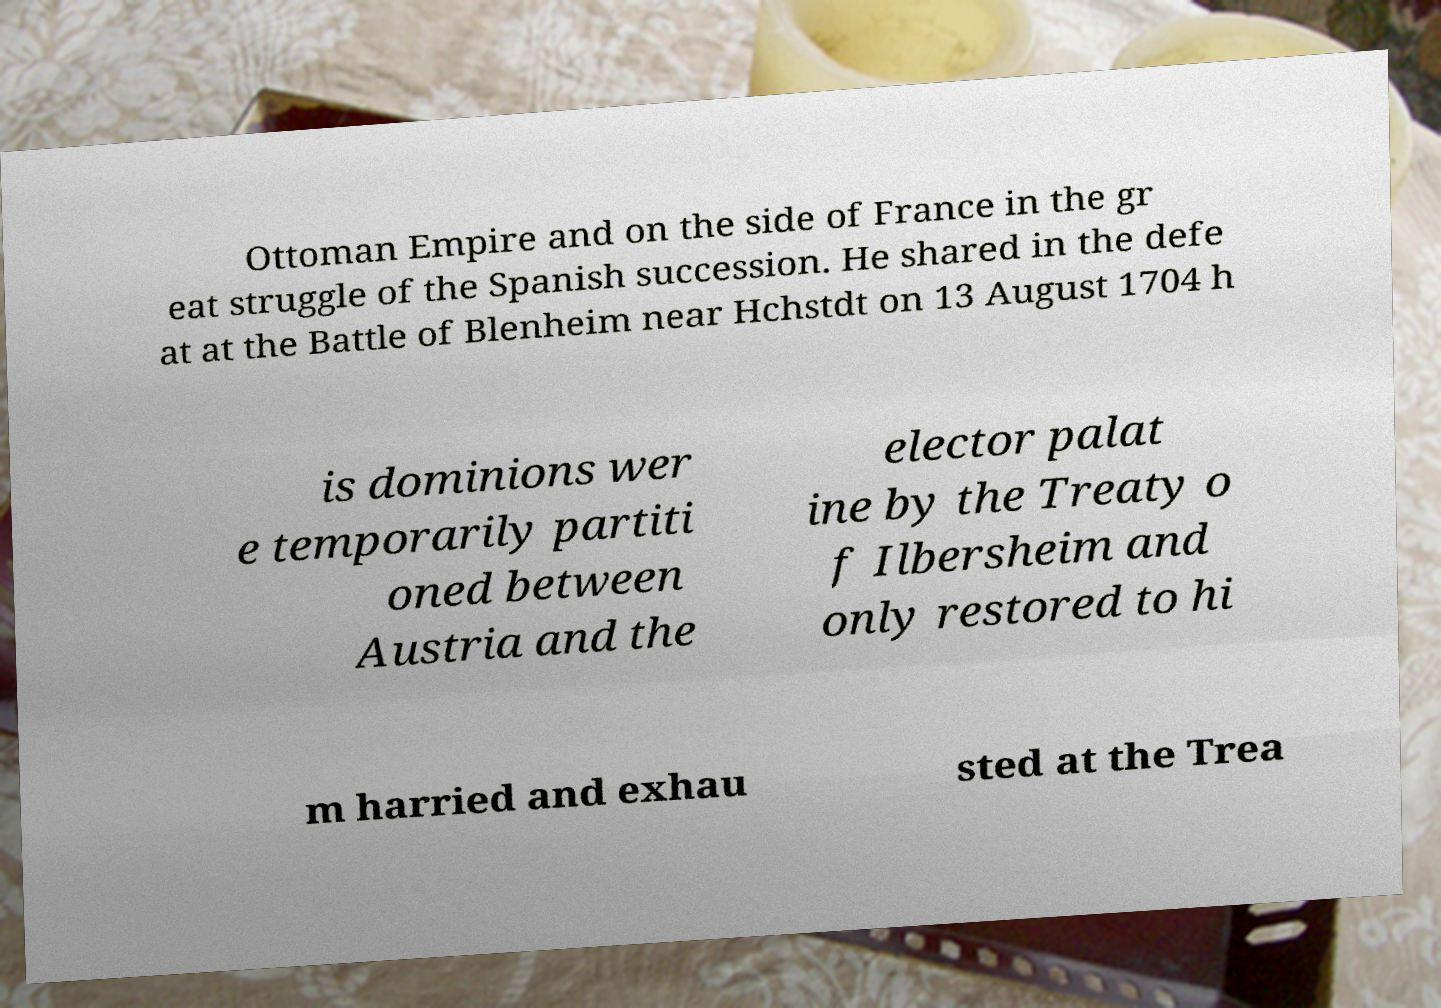There's text embedded in this image that I need extracted. Can you transcribe it verbatim? Ottoman Empire and on the side of France in the gr eat struggle of the Spanish succession. He shared in the defe at at the Battle of Blenheim near Hchstdt on 13 August 1704 h is dominions wer e temporarily partiti oned between Austria and the elector palat ine by the Treaty o f Ilbersheim and only restored to hi m harried and exhau sted at the Trea 